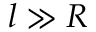<formula> <loc_0><loc_0><loc_500><loc_500>l \gg R</formula> 